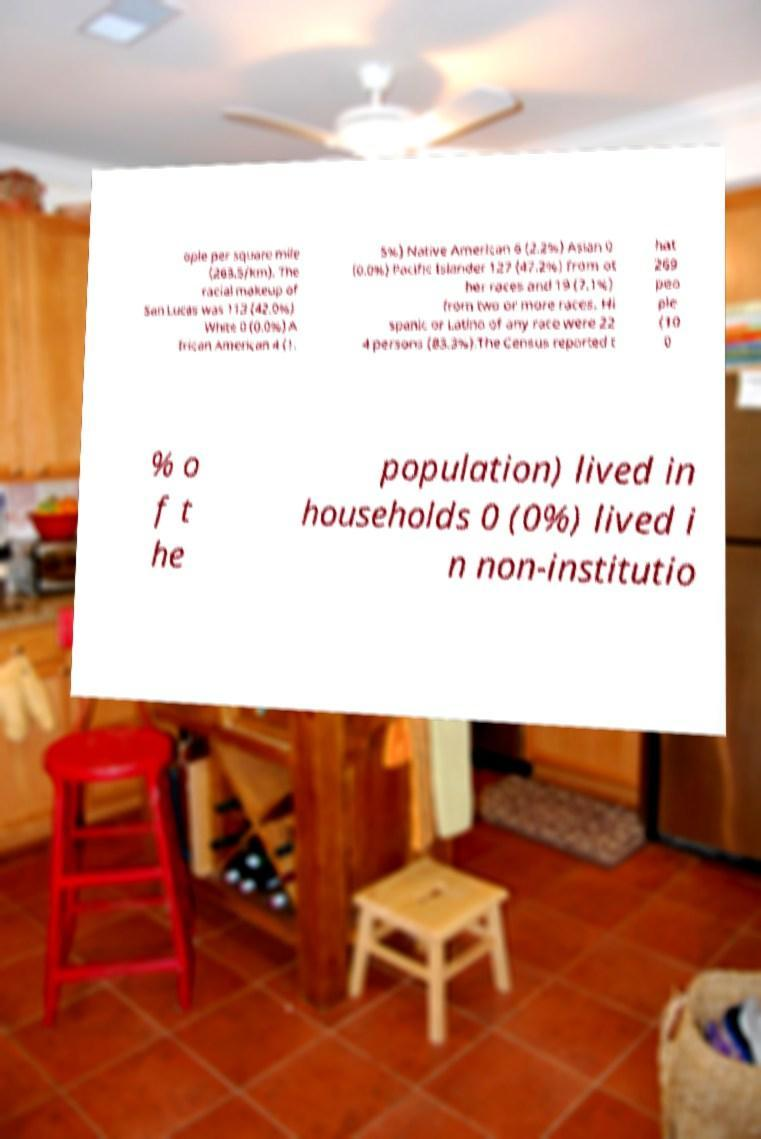Please read and relay the text visible in this image. What does it say? ople per square mile (263.5/km). The racial makeup of San Lucas was 113 (42.0%) White 0 (0.0%) A frican American 4 (1. 5%) Native American 6 (2.2%) Asian 0 (0.0%) Pacific Islander 127 (47.2%) from ot her races and 19 (7.1%) from two or more races. Hi spanic or Latino of any race were 22 4 persons (83.3%).The Census reported t hat 269 peo ple (10 0 % o f t he population) lived in households 0 (0%) lived i n non-institutio 